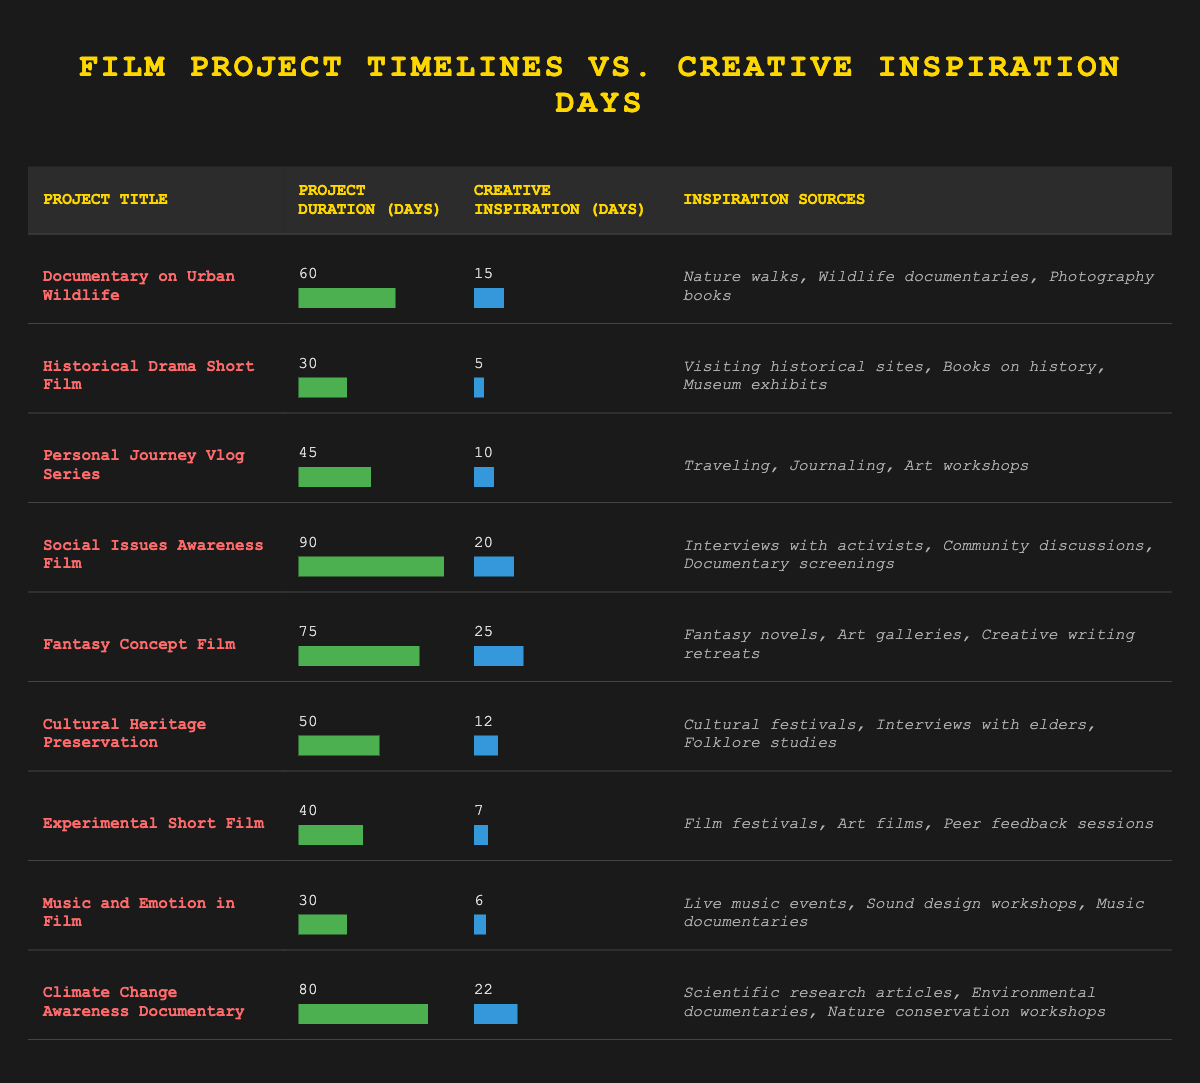What is the project duration of the "Fantasy Concept Film"? From the table, we can find the row corresponding to the "Fantasy Concept Film." The project duration is listed as 75 days.
Answer: 75 days Which film project has the highest number of creative inspiration days? By scanning the "Creative Inspiration (days)" column, we can identify the row with the highest value. The "Fantasy Concept Film" has 25 creative inspiration days, which is the highest among all projects listed.
Answer: Fantasy Concept Film How many total days are allocated for creative inspiration across all projects? Adding the creative inspiration days for all projects gives us: 15 + 5 + 10 + 20 + 25 + 12 + 7 + 6 + 22 = 122. Thus, the total creative inspiration days is 122.
Answer: 122 days Is the project duration of the "Music and Emotion in Film" shorter than that of the "Cultural Heritage Preservation"? The "Music and Emotion in Film" has a project duration of 30 days, while the "Cultural Heritage Preservation" has 50 days. Since 30 is less than 50, the statement is true.
Answer: Yes What is the average project duration of all film projects? To find the average, we sum the project durations: 60 + 30 + 45 + 90 + 75 + 50 + 40 + 30 + 80 = 460. There are 9 projects, so the average project duration is 460/9 ≈ 51.11 days.
Answer: 51.11 days Are there any projects that have both a project duration of 40 days or less and creative inspiration days of more than 10? Examining the projects, "Experimental Short Film" has a duration of 40 days but only 7 inspiration days, while "Music and Emotion in Film" has 30 days and 6 inspiration days. No projects fall under the criteria of both conditions.
Answer: No What is the difference in creative inspiration days between the "Social Issues Awareness Film" and the "Historical Drama Short Film"? The "Social Issues Awareness Film" has 20 inspiration days, and the "Historical Drama Short Film" has 5. The difference is 20 - 5 = 15.
Answer: 15 days Which project has the least amount of creative inspiration days, and what is its duration? Looking through the data, we find that the "Music and Emotion in Film" has the least creative inspiration days, which totals 6 days. It has a project duration of 30 days.
Answer: Music and Emotion in Film, 30 days How many projects have a project duration of more than 60 days? Reviewing the project durations in the table, "Social Issues Awareness Film" and "Climate Change Awareness Documentary" exceed 60 days, totaling 2 projects.
Answer: 2 projects 